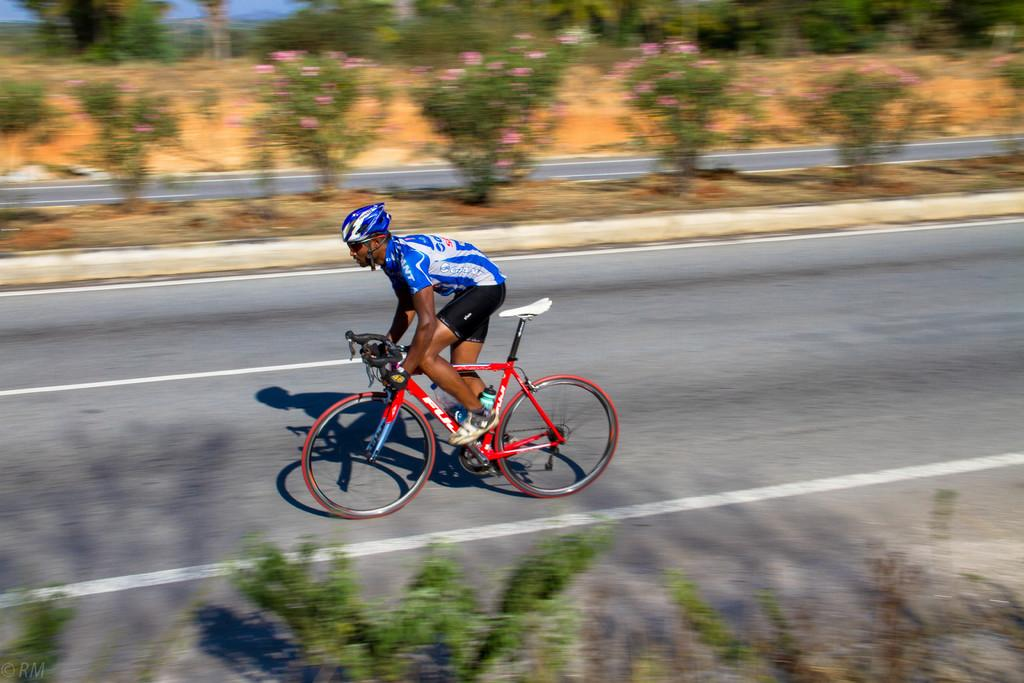What is the main subject of the image? There is a person in the image. What is the person doing in the image? The person is riding a cycle. Where is the cycle located? The cycle is on a road. What can be seen beside the road? There are many plants beside the road. What type of whip is the person using to control the beast in the image? There is no whip or beast present in the image; the person is riding a cycle on a road. Can you tell me what kind of cheese the person is holding while riding the cycle? There is no cheese present in the image; the person is simply riding a cycle on a road. 